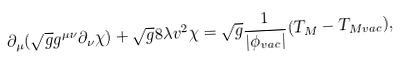<formula> <loc_0><loc_0><loc_500><loc_500>\partial _ { \mu } ( \sqrt { g } g ^ { \mu \nu } \partial _ { \nu } \chi ) + \sqrt { g } 8 \lambda v ^ { 2 } \chi = \sqrt { g } \frac { 1 } { | \phi _ { v a c } | } ( T _ { M } - T _ { M v a c } ) ,</formula> 